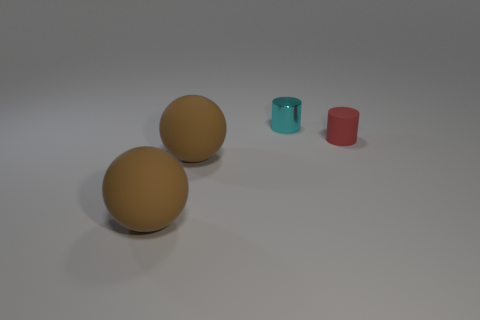How many small things are cyan metallic cylinders or red cylinders?
Give a very brief answer. 2. What number of small gray objects are the same shape as the cyan thing?
Ensure brevity in your answer.  0. There is a cyan metallic thing; is its shape the same as the tiny thing in front of the cyan shiny object?
Offer a terse response. Yes. There is a small cyan cylinder; what number of large brown rubber spheres are behind it?
Your answer should be very brief. 0. Is there a matte thing that has the same size as the shiny object?
Provide a succinct answer. Yes. The matte cylinder is what color?
Ensure brevity in your answer.  Red. Are any tiny green matte blocks visible?
Give a very brief answer. No. There is a thing behind the tiny cylinder in front of the cylinder that is on the left side of the small rubber cylinder; what shape is it?
Ensure brevity in your answer.  Cylinder. Are there an equal number of red rubber things to the right of the red rubber object and cyan metallic objects?
Your answer should be compact. No. How many objects are either cylinders that are left of the tiny rubber thing or brown spheres?
Offer a terse response. 3. 